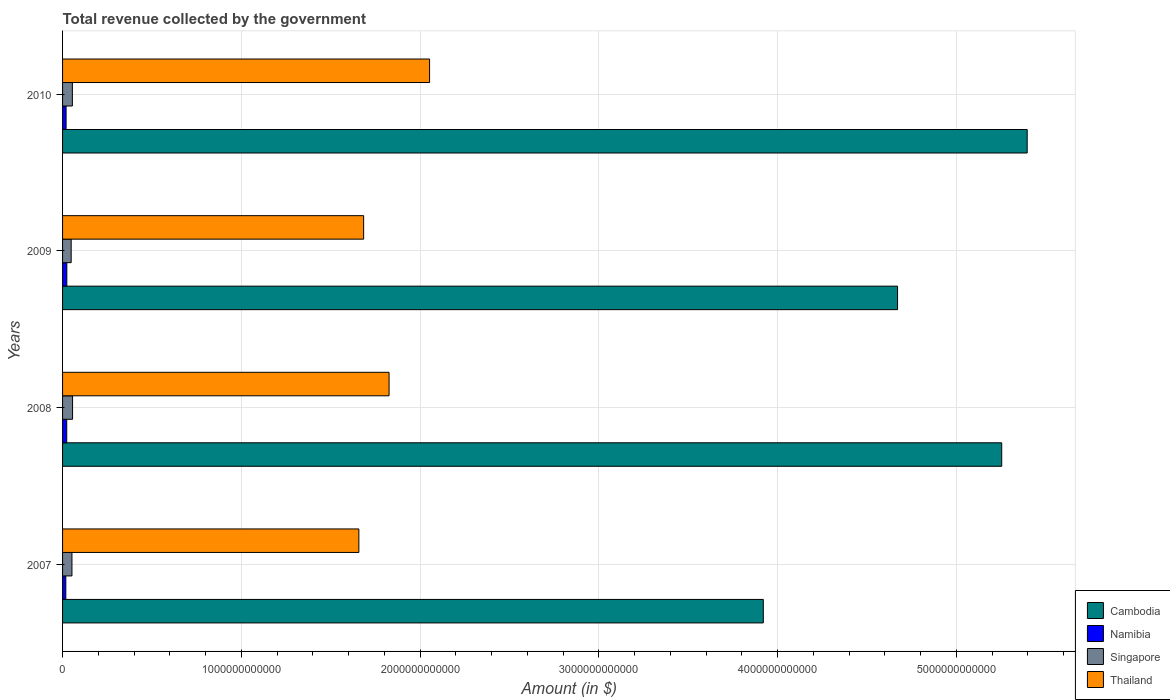How many groups of bars are there?
Your answer should be compact. 4. Are the number of bars per tick equal to the number of legend labels?
Keep it short and to the point. Yes. How many bars are there on the 1st tick from the top?
Keep it short and to the point. 4. How many bars are there on the 4th tick from the bottom?
Give a very brief answer. 4. What is the label of the 1st group of bars from the top?
Provide a succinct answer. 2010. In how many cases, is the number of bars for a given year not equal to the number of legend labels?
Keep it short and to the point. 0. What is the total revenue collected by the government in Namibia in 2008?
Provide a succinct answer. 2.33e+1. Across all years, what is the maximum total revenue collected by the government in Thailand?
Your answer should be very brief. 2.05e+12. Across all years, what is the minimum total revenue collected by the government in Singapore?
Offer a terse response. 4.82e+1. What is the total total revenue collected by the government in Namibia in the graph?
Give a very brief answer. 8.49e+1. What is the difference between the total revenue collected by the government in Cambodia in 2008 and that in 2010?
Your answer should be very brief. -1.42e+11. What is the difference between the total revenue collected by the government in Singapore in 2009 and the total revenue collected by the government in Thailand in 2007?
Your response must be concise. -1.61e+12. What is the average total revenue collected by the government in Singapore per year?
Give a very brief answer. 5.29e+1. In the year 2008, what is the difference between the total revenue collected by the government in Thailand and total revenue collected by the government in Cambodia?
Provide a succinct answer. -3.43e+12. In how many years, is the total revenue collected by the government in Namibia greater than 3200000000000 $?
Your response must be concise. 0. What is the ratio of the total revenue collected by the government in Thailand in 2007 to that in 2009?
Your answer should be compact. 0.98. Is the total revenue collected by the government in Cambodia in 2009 less than that in 2010?
Offer a terse response. Yes. What is the difference between the highest and the second highest total revenue collected by the government in Namibia?
Give a very brief answer. 5.30e+08. What is the difference between the highest and the lowest total revenue collected by the government in Namibia?
Give a very brief answer. 5.70e+09. In how many years, is the total revenue collected by the government in Thailand greater than the average total revenue collected by the government in Thailand taken over all years?
Keep it short and to the point. 2. Is the sum of the total revenue collected by the government in Cambodia in 2007 and 2008 greater than the maximum total revenue collected by the government in Singapore across all years?
Ensure brevity in your answer.  Yes. Is it the case that in every year, the sum of the total revenue collected by the government in Thailand and total revenue collected by the government in Namibia is greater than the sum of total revenue collected by the government in Singapore and total revenue collected by the government in Cambodia?
Provide a succinct answer. No. What does the 1st bar from the top in 2007 represents?
Keep it short and to the point. Thailand. What does the 2nd bar from the bottom in 2010 represents?
Keep it short and to the point. Namibia. What is the difference between two consecutive major ticks on the X-axis?
Keep it short and to the point. 1.00e+12. Are the values on the major ticks of X-axis written in scientific E-notation?
Make the answer very short. No. Does the graph contain grids?
Provide a short and direct response. Yes. What is the title of the graph?
Your answer should be very brief. Total revenue collected by the government. Does "Bhutan" appear as one of the legend labels in the graph?
Keep it short and to the point. No. What is the label or title of the X-axis?
Offer a terse response. Amount (in $). What is the Amount (in $) in Cambodia in 2007?
Offer a terse response. 3.92e+12. What is the Amount (in $) of Namibia in 2007?
Your response must be concise. 1.82e+1. What is the Amount (in $) in Singapore in 2007?
Make the answer very short. 5.25e+1. What is the Amount (in $) in Thailand in 2007?
Make the answer very short. 1.66e+12. What is the Amount (in $) in Cambodia in 2008?
Your response must be concise. 5.25e+12. What is the Amount (in $) in Namibia in 2008?
Offer a very short reply. 2.33e+1. What is the Amount (in $) in Singapore in 2008?
Give a very brief answer. 5.59e+1. What is the Amount (in $) in Thailand in 2008?
Ensure brevity in your answer.  1.83e+12. What is the Amount (in $) of Cambodia in 2009?
Provide a short and direct response. 4.67e+12. What is the Amount (in $) of Namibia in 2009?
Provide a succinct answer. 2.38e+1. What is the Amount (in $) in Singapore in 2009?
Ensure brevity in your answer.  4.82e+1. What is the Amount (in $) of Thailand in 2009?
Provide a succinct answer. 1.68e+12. What is the Amount (in $) in Cambodia in 2010?
Keep it short and to the point. 5.40e+12. What is the Amount (in $) of Namibia in 2010?
Offer a very short reply. 1.96e+1. What is the Amount (in $) of Singapore in 2010?
Your answer should be compact. 5.49e+1. What is the Amount (in $) in Thailand in 2010?
Your answer should be compact. 2.05e+12. Across all years, what is the maximum Amount (in $) of Cambodia?
Give a very brief answer. 5.40e+12. Across all years, what is the maximum Amount (in $) in Namibia?
Offer a very short reply. 2.38e+1. Across all years, what is the maximum Amount (in $) in Singapore?
Ensure brevity in your answer.  5.59e+1. Across all years, what is the maximum Amount (in $) of Thailand?
Your answer should be very brief. 2.05e+12. Across all years, what is the minimum Amount (in $) in Cambodia?
Keep it short and to the point. 3.92e+12. Across all years, what is the minimum Amount (in $) in Namibia?
Keep it short and to the point. 1.82e+1. Across all years, what is the minimum Amount (in $) of Singapore?
Offer a very short reply. 4.82e+1. Across all years, what is the minimum Amount (in $) in Thailand?
Offer a terse response. 1.66e+12. What is the total Amount (in $) in Cambodia in the graph?
Offer a terse response. 1.92e+13. What is the total Amount (in $) in Namibia in the graph?
Provide a short and direct response. 8.49e+1. What is the total Amount (in $) in Singapore in the graph?
Make the answer very short. 2.11e+11. What is the total Amount (in $) in Thailand in the graph?
Make the answer very short. 7.22e+12. What is the difference between the Amount (in $) of Cambodia in 2007 and that in 2008?
Give a very brief answer. -1.33e+12. What is the difference between the Amount (in $) of Namibia in 2007 and that in 2008?
Make the answer very short. -5.16e+09. What is the difference between the Amount (in $) of Singapore in 2007 and that in 2008?
Your response must be concise. -3.43e+09. What is the difference between the Amount (in $) of Thailand in 2007 and that in 2008?
Your answer should be very brief. -1.69e+11. What is the difference between the Amount (in $) of Cambodia in 2007 and that in 2009?
Make the answer very short. -7.51e+11. What is the difference between the Amount (in $) in Namibia in 2007 and that in 2009?
Provide a succinct answer. -5.70e+09. What is the difference between the Amount (in $) in Singapore in 2007 and that in 2009?
Your response must be concise. 4.33e+09. What is the difference between the Amount (in $) of Thailand in 2007 and that in 2009?
Offer a terse response. -2.67e+1. What is the difference between the Amount (in $) in Cambodia in 2007 and that in 2010?
Your response must be concise. -1.48e+12. What is the difference between the Amount (in $) of Namibia in 2007 and that in 2010?
Your response must be concise. -1.49e+09. What is the difference between the Amount (in $) of Singapore in 2007 and that in 2010?
Ensure brevity in your answer.  -2.37e+09. What is the difference between the Amount (in $) of Thailand in 2007 and that in 2010?
Offer a terse response. -3.96e+11. What is the difference between the Amount (in $) of Cambodia in 2008 and that in 2009?
Offer a very short reply. 5.83e+11. What is the difference between the Amount (in $) in Namibia in 2008 and that in 2009?
Provide a short and direct response. -5.30e+08. What is the difference between the Amount (in $) in Singapore in 2008 and that in 2009?
Your answer should be very brief. 7.76e+09. What is the difference between the Amount (in $) of Thailand in 2008 and that in 2009?
Provide a succinct answer. 1.42e+11. What is the difference between the Amount (in $) of Cambodia in 2008 and that in 2010?
Offer a very short reply. -1.42e+11. What is the difference between the Amount (in $) in Namibia in 2008 and that in 2010?
Provide a short and direct response. 3.68e+09. What is the difference between the Amount (in $) in Singapore in 2008 and that in 2010?
Provide a short and direct response. 1.06e+09. What is the difference between the Amount (in $) of Thailand in 2008 and that in 2010?
Keep it short and to the point. -2.27e+11. What is the difference between the Amount (in $) in Cambodia in 2009 and that in 2010?
Give a very brief answer. -7.25e+11. What is the difference between the Amount (in $) of Namibia in 2009 and that in 2010?
Provide a succinct answer. 4.21e+09. What is the difference between the Amount (in $) of Singapore in 2009 and that in 2010?
Provide a succinct answer. -6.70e+09. What is the difference between the Amount (in $) of Thailand in 2009 and that in 2010?
Keep it short and to the point. -3.69e+11. What is the difference between the Amount (in $) in Cambodia in 2007 and the Amount (in $) in Namibia in 2008?
Your answer should be compact. 3.90e+12. What is the difference between the Amount (in $) of Cambodia in 2007 and the Amount (in $) of Singapore in 2008?
Provide a short and direct response. 3.86e+12. What is the difference between the Amount (in $) of Cambodia in 2007 and the Amount (in $) of Thailand in 2008?
Your answer should be very brief. 2.09e+12. What is the difference between the Amount (in $) in Namibia in 2007 and the Amount (in $) in Singapore in 2008?
Ensure brevity in your answer.  -3.78e+1. What is the difference between the Amount (in $) of Namibia in 2007 and the Amount (in $) of Thailand in 2008?
Offer a very short reply. -1.81e+12. What is the difference between the Amount (in $) in Singapore in 2007 and the Amount (in $) in Thailand in 2008?
Give a very brief answer. -1.77e+12. What is the difference between the Amount (in $) in Cambodia in 2007 and the Amount (in $) in Namibia in 2009?
Offer a very short reply. 3.90e+12. What is the difference between the Amount (in $) of Cambodia in 2007 and the Amount (in $) of Singapore in 2009?
Make the answer very short. 3.87e+12. What is the difference between the Amount (in $) in Cambodia in 2007 and the Amount (in $) in Thailand in 2009?
Give a very brief answer. 2.24e+12. What is the difference between the Amount (in $) in Namibia in 2007 and the Amount (in $) in Singapore in 2009?
Ensure brevity in your answer.  -3.00e+1. What is the difference between the Amount (in $) in Namibia in 2007 and the Amount (in $) in Thailand in 2009?
Your answer should be compact. -1.67e+12. What is the difference between the Amount (in $) in Singapore in 2007 and the Amount (in $) in Thailand in 2009?
Give a very brief answer. -1.63e+12. What is the difference between the Amount (in $) in Cambodia in 2007 and the Amount (in $) in Namibia in 2010?
Keep it short and to the point. 3.90e+12. What is the difference between the Amount (in $) in Cambodia in 2007 and the Amount (in $) in Singapore in 2010?
Your answer should be compact. 3.87e+12. What is the difference between the Amount (in $) in Cambodia in 2007 and the Amount (in $) in Thailand in 2010?
Your response must be concise. 1.87e+12. What is the difference between the Amount (in $) in Namibia in 2007 and the Amount (in $) in Singapore in 2010?
Provide a short and direct response. -3.67e+1. What is the difference between the Amount (in $) of Namibia in 2007 and the Amount (in $) of Thailand in 2010?
Provide a succinct answer. -2.04e+12. What is the difference between the Amount (in $) in Singapore in 2007 and the Amount (in $) in Thailand in 2010?
Keep it short and to the point. -2.00e+12. What is the difference between the Amount (in $) of Cambodia in 2008 and the Amount (in $) of Namibia in 2009?
Provide a succinct answer. 5.23e+12. What is the difference between the Amount (in $) of Cambodia in 2008 and the Amount (in $) of Singapore in 2009?
Your response must be concise. 5.21e+12. What is the difference between the Amount (in $) of Cambodia in 2008 and the Amount (in $) of Thailand in 2009?
Make the answer very short. 3.57e+12. What is the difference between the Amount (in $) in Namibia in 2008 and the Amount (in $) in Singapore in 2009?
Provide a short and direct response. -2.48e+1. What is the difference between the Amount (in $) of Namibia in 2008 and the Amount (in $) of Thailand in 2009?
Provide a succinct answer. -1.66e+12. What is the difference between the Amount (in $) in Singapore in 2008 and the Amount (in $) in Thailand in 2009?
Your answer should be compact. -1.63e+12. What is the difference between the Amount (in $) of Cambodia in 2008 and the Amount (in $) of Namibia in 2010?
Provide a short and direct response. 5.23e+12. What is the difference between the Amount (in $) in Cambodia in 2008 and the Amount (in $) in Singapore in 2010?
Provide a succinct answer. 5.20e+12. What is the difference between the Amount (in $) of Cambodia in 2008 and the Amount (in $) of Thailand in 2010?
Your answer should be compact. 3.20e+12. What is the difference between the Amount (in $) in Namibia in 2008 and the Amount (in $) in Singapore in 2010?
Provide a short and direct response. -3.15e+1. What is the difference between the Amount (in $) of Namibia in 2008 and the Amount (in $) of Thailand in 2010?
Ensure brevity in your answer.  -2.03e+12. What is the difference between the Amount (in $) in Singapore in 2008 and the Amount (in $) in Thailand in 2010?
Offer a very short reply. -2.00e+12. What is the difference between the Amount (in $) in Cambodia in 2009 and the Amount (in $) in Namibia in 2010?
Ensure brevity in your answer.  4.65e+12. What is the difference between the Amount (in $) in Cambodia in 2009 and the Amount (in $) in Singapore in 2010?
Offer a terse response. 4.62e+12. What is the difference between the Amount (in $) in Cambodia in 2009 and the Amount (in $) in Thailand in 2010?
Your response must be concise. 2.62e+12. What is the difference between the Amount (in $) of Namibia in 2009 and the Amount (in $) of Singapore in 2010?
Make the answer very short. -3.10e+1. What is the difference between the Amount (in $) in Namibia in 2009 and the Amount (in $) in Thailand in 2010?
Your answer should be very brief. -2.03e+12. What is the difference between the Amount (in $) in Singapore in 2009 and the Amount (in $) in Thailand in 2010?
Make the answer very short. -2.01e+12. What is the average Amount (in $) in Cambodia per year?
Offer a terse response. 4.81e+12. What is the average Amount (in $) in Namibia per year?
Offer a very short reply. 2.12e+1. What is the average Amount (in $) of Singapore per year?
Your answer should be compact. 5.29e+1. What is the average Amount (in $) in Thailand per year?
Ensure brevity in your answer.  1.81e+12. In the year 2007, what is the difference between the Amount (in $) in Cambodia and Amount (in $) in Namibia?
Provide a short and direct response. 3.90e+12. In the year 2007, what is the difference between the Amount (in $) in Cambodia and Amount (in $) in Singapore?
Make the answer very short. 3.87e+12. In the year 2007, what is the difference between the Amount (in $) in Cambodia and Amount (in $) in Thailand?
Your answer should be compact. 2.26e+12. In the year 2007, what is the difference between the Amount (in $) of Namibia and Amount (in $) of Singapore?
Ensure brevity in your answer.  -3.43e+1. In the year 2007, what is the difference between the Amount (in $) of Namibia and Amount (in $) of Thailand?
Provide a succinct answer. -1.64e+12. In the year 2007, what is the difference between the Amount (in $) of Singapore and Amount (in $) of Thailand?
Offer a very short reply. -1.61e+12. In the year 2008, what is the difference between the Amount (in $) of Cambodia and Amount (in $) of Namibia?
Your answer should be very brief. 5.23e+12. In the year 2008, what is the difference between the Amount (in $) in Cambodia and Amount (in $) in Singapore?
Make the answer very short. 5.20e+12. In the year 2008, what is the difference between the Amount (in $) of Cambodia and Amount (in $) of Thailand?
Your response must be concise. 3.43e+12. In the year 2008, what is the difference between the Amount (in $) in Namibia and Amount (in $) in Singapore?
Provide a short and direct response. -3.26e+1. In the year 2008, what is the difference between the Amount (in $) in Namibia and Amount (in $) in Thailand?
Your response must be concise. -1.80e+12. In the year 2008, what is the difference between the Amount (in $) in Singapore and Amount (in $) in Thailand?
Give a very brief answer. -1.77e+12. In the year 2009, what is the difference between the Amount (in $) of Cambodia and Amount (in $) of Namibia?
Offer a terse response. 4.65e+12. In the year 2009, what is the difference between the Amount (in $) of Cambodia and Amount (in $) of Singapore?
Your response must be concise. 4.62e+12. In the year 2009, what is the difference between the Amount (in $) in Cambodia and Amount (in $) in Thailand?
Provide a short and direct response. 2.99e+12. In the year 2009, what is the difference between the Amount (in $) in Namibia and Amount (in $) in Singapore?
Offer a terse response. -2.43e+1. In the year 2009, what is the difference between the Amount (in $) in Namibia and Amount (in $) in Thailand?
Give a very brief answer. -1.66e+12. In the year 2009, what is the difference between the Amount (in $) in Singapore and Amount (in $) in Thailand?
Provide a succinct answer. -1.64e+12. In the year 2010, what is the difference between the Amount (in $) of Cambodia and Amount (in $) of Namibia?
Give a very brief answer. 5.38e+12. In the year 2010, what is the difference between the Amount (in $) of Cambodia and Amount (in $) of Singapore?
Give a very brief answer. 5.34e+12. In the year 2010, what is the difference between the Amount (in $) of Cambodia and Amount (in $) of Thailand?
Give a very brief answer. 3.34e+12. In the year 2010, what is the difference between the Amount (in $) of Namibia and Amount (in $) of Singapore?
Offer a terse response. -3.52e+1. In the year 2010, what is the difference between the Amount (in $) of Namibia and Amount (in $) of Thailand?
Provide a succinct answer. -2.03e+12. In the year 2010, what is the difference between the Amount (in $) of Singapore and Amount (in $) of Thailand?
Provide a short and direct response. -2.00e+12. What is the ratio of the Amount (in $) in Cambodia in 2007 to that in 2008?
Give a very brief answer. 0.75. What is the ratio of the Amount (in $) in Namibia in 2007 to that in 2008?
Your answer should be compact. 0.78. What is the ratio of the Amount (in $) in Singapore in 2007 to that in 2008?
Ensure brevity in your answer.  0.94. What is the ratio of the Amount (in $) in Thailand in 2007 to that in 2008?
Offer a very short reply. 0.91. What is the ratio of the Amount (in $) in Cambodia in 2007 to that in 2009?
Offer a terse response. 0.84. What is the ratio of the Amount (in $) in Namibia in 2007 to that in 2009?
Your answer should be compact. 0.76. What is the ratio of the Amount (in $) in Singapore in 2007 to that in 2009?
Offer a terse response. 1.09. What is the ratio of the Amount (in $) in Thailand in 2007 to that in 2009?
Offer a terse response. 0.98. What is the ratio of the Amount (in $) in Cambodia in 2007 to that in 2010?
Your response must be concise. 0.73. What is the ratio of the Amount (in $) of Namibia in 2007 to that in 2010?
Your answer should be very brief. 0.92. What is the ratio of the Amount (in $) in Singapore in 2007 to that in 2010?
Make the answer very short. 0.96. What is the ratio of the Amount (in $) of Thailand in 2007 to that in 2010?
Make the answer very short. 0.81. What is the ratio of the Amount (in $) of Cambodia in 2008 to that in 2009?
Offer a very short reply. 1.12. What is the ratio of the Amount (in $) of Namibia in 2008 to that in 2009?
Provide a short and direct response. 0.98. What is the ratio of the Amount (in $) of Singapore in 2008 to that in 2009?
Offer a very short reply. 1.16. What is the ratio of the Amount (in $) of Thailand in 2008 to that in 2009?
Provide a short and direct response. 1.08. What is the ratio of the Amount (in $) in Cambodia in 2008 to that in 2010?
Provide a succinct answer. 0.97. What is the ratio of the Amount (in $) of Namibia in 2008 to that in 2010?
Your answer should be compact. 1.19. What is the ratio of the Amount (in $) of Singapore in 2008 to that in 2010?
Make the answer very short. 1.02. What is the ratio of the Amount (in $) in Thailand in 2008 to that in 2010?
Your answer should be compact. 0.89. What is the ratio of the Amount (in $) of Cambodia in 2009 to that in 2010?
Ensure brevity in your answer.  0.87. What is the ratio of the Amount (in $) in Namibia in 2009 to that in 2010?
Make the answer very short. 1.21. What is the ratio of the Amount (in $) of Singapore in 2009 to that in 2010?
Offer a very short reply. 0.88. What is the ratio of the Amount (in $) of Thailand in 2009 to that in 2010?
Ensure brevity in your answer.  0.82. What is the difference between the highest and the second highest Amount (in $) in Cambodia?
Make the answer very short. 1.42e+11. What is the difference between the highest and the second highest Amount (in $) in Namibia?
Your answer should be very brief. 5.30e+08. What is the difference between the highest and the second highest Amount (in $) in Singapore?
Your answer should be compact. 1.06e+09. What is the difference between the highest and the second highest Amount (in $) of Thailand?
Provide a succinct answer. 2.27e+11. What is the difference between the highest and the lowest Amount (in $) of Cambodia?
Give a very brief answer. 1.48e+12. What is the difference between the highest and the lowest Amount (in $) of Namibia?
Your response must be concise. 5.70e+09. What is the difference between the highest and the lowest Amount (in $) in Singapore?
Your response must be concise. 7.76e+09. What is the difference between the highest and the lowest Amount (in $) of Thailand?
Ensure brevity in your answer.  3.96e+11. 